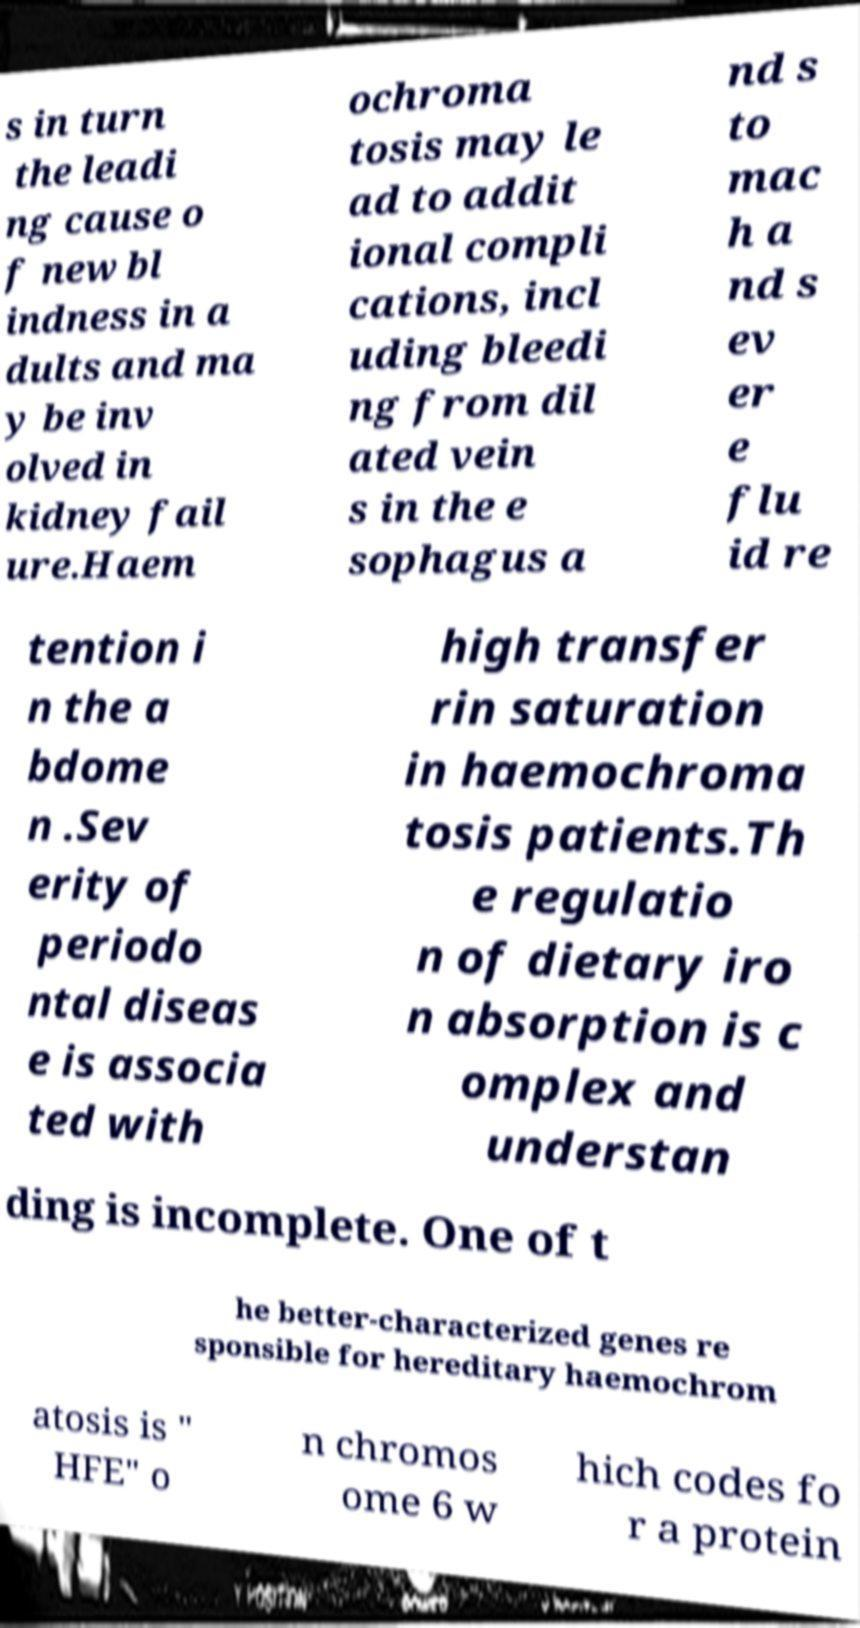There's text embedded in this image that I need extracted. Can you transcribe it verbatim? s in turn the leadi ng cause o f new bl indness in a dults and ma y be inv olved in kidney fail ure.Haem ochroma tosis may le ad to addit ional compli cations, incl uding bleedi ng from dil ated vein s in the e sophagus a nd s to mac h a nd s ev er e flu id re tention i n the a bdome n .Sev erity of periodo ntal diseas e is associa ted with high transfer rin saturation in haemochroma tosis patients.Th e regulatio n of dietary iro n absorption is c omplex and understan ding is incomplete. One of t he better-characterized genes re sponsible for hereditary haemochrom atosis is " HFE" o n chromos ome 6 w hich codes fo r a protein 